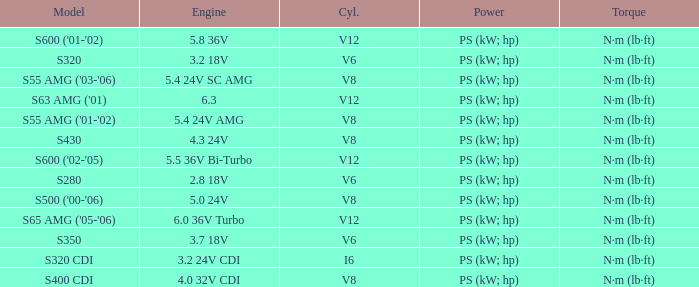Which Engine has a Model of s320 cdi? 3.2 24V CDI. 